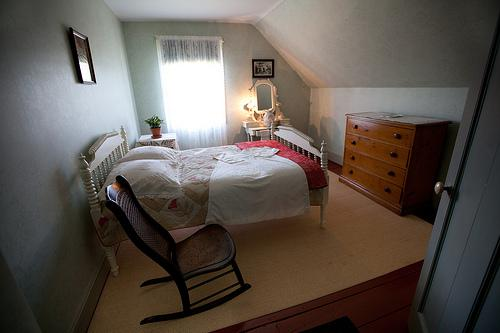Question: when was the picture taken?
Choices:
A. In the sunlight.
B. Yesterday.
C. When it was light out.
D. During the day.
Answer with the letter. Answer: D Question: what is near the window?
Choices:
A. Mirror.
B. Painting.
C. Curtain.
D. Tv.
Answer with the letter. Answer: A 